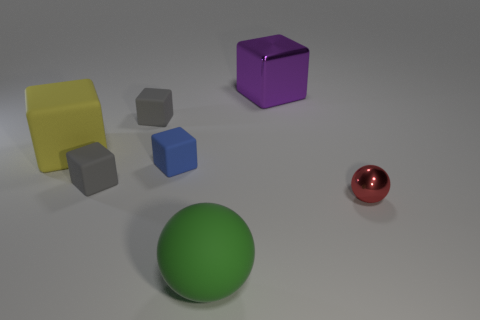How would you describe the surface on which the objects are placed? The objects are resting on a smooth, matte surface that has a slight gradient of light, suggesting a subtle curvature. Its neutral color helps accentuate the colors and shapes of the objects placed upon it. 